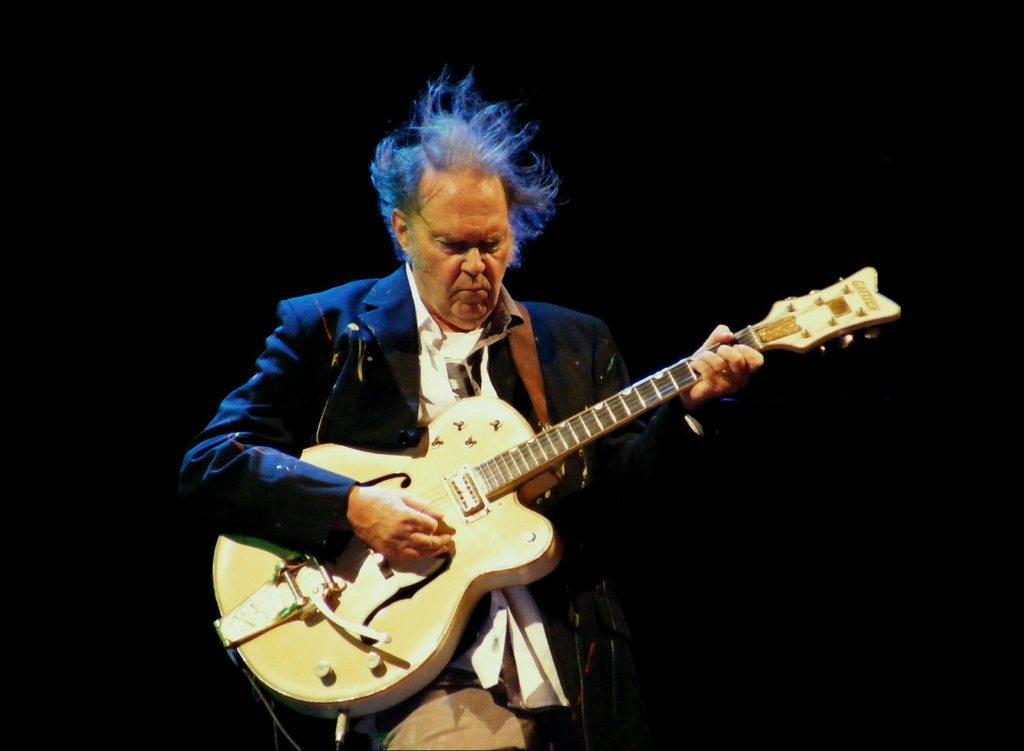How would you summarize this image in a sentence or two? In the center of the image we can see a person holding guitar in his hands. 